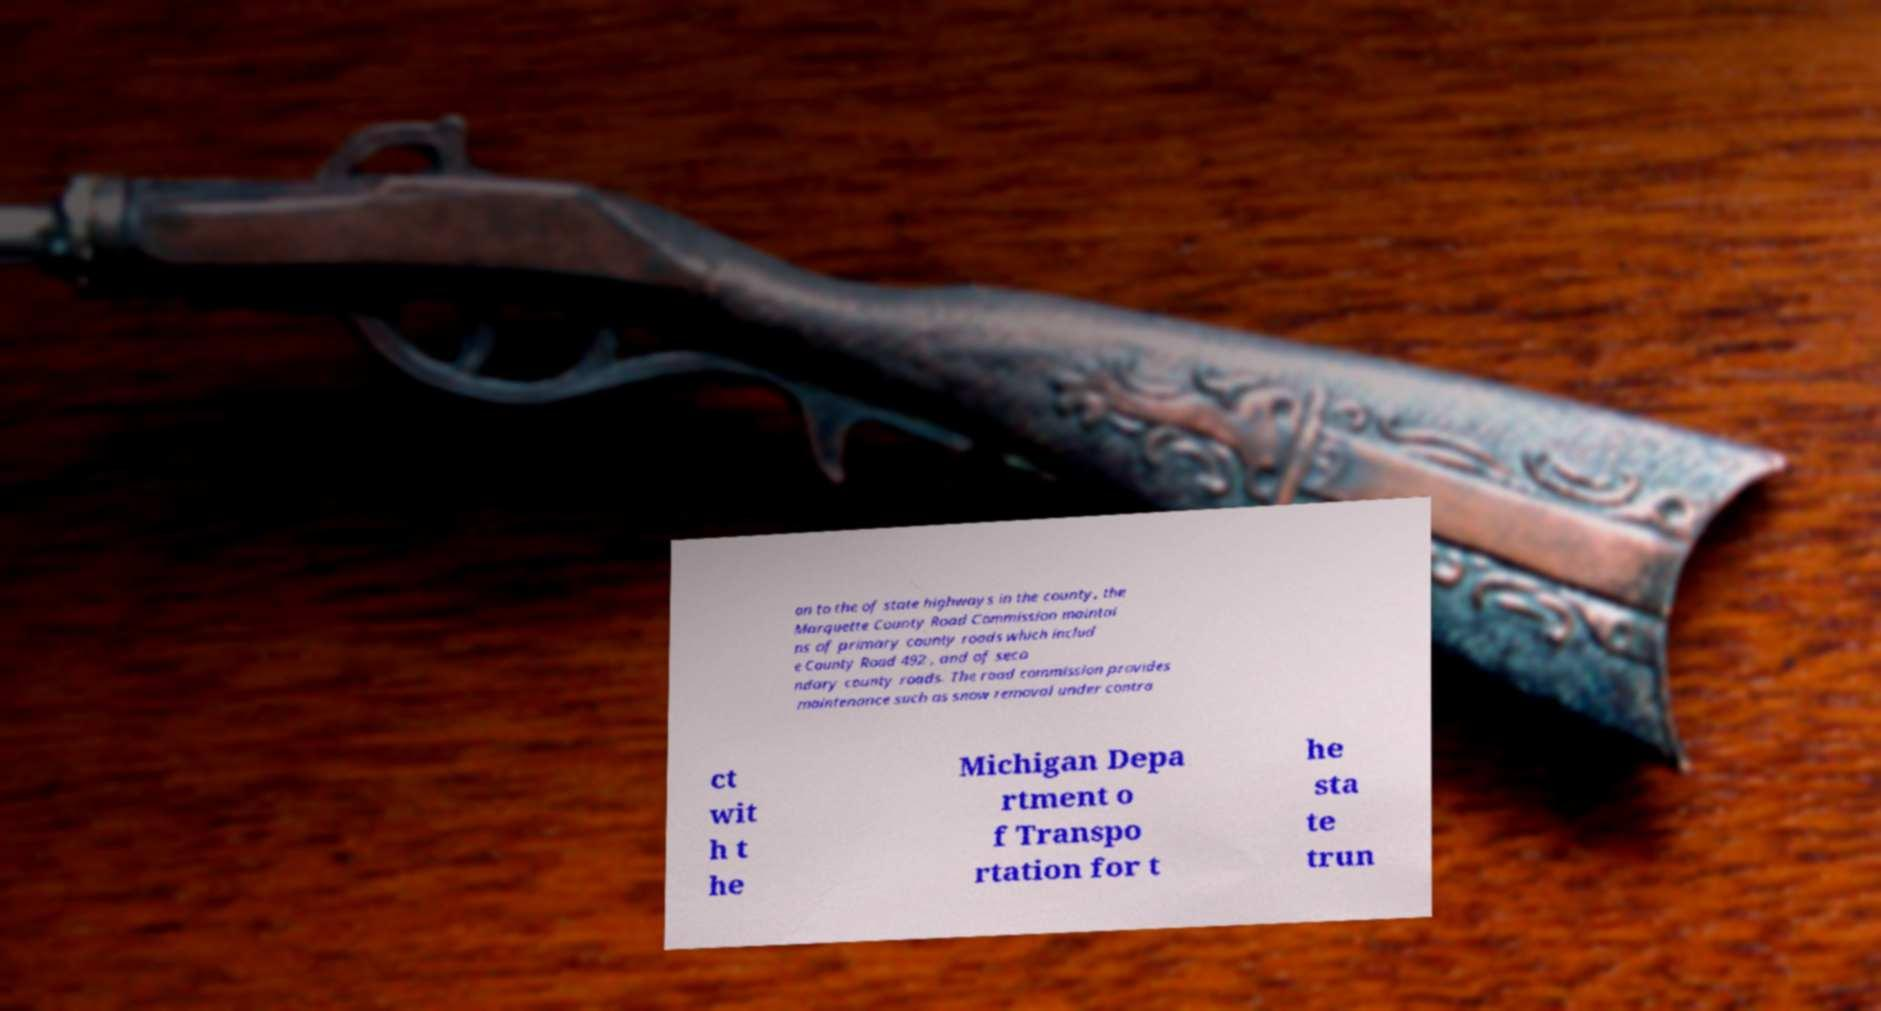Could you extract and type out the text from this image? on to the of state highways in the county, the Marquette County Road Commission maintai ns of primary county roads which includ e County Road 492 , and of seco ndary county roads. The road commission provides maintenance such as snow removal under contra ct wit h t he Michigan Depa rtment o f Transpo rtation for t he sta te trun 